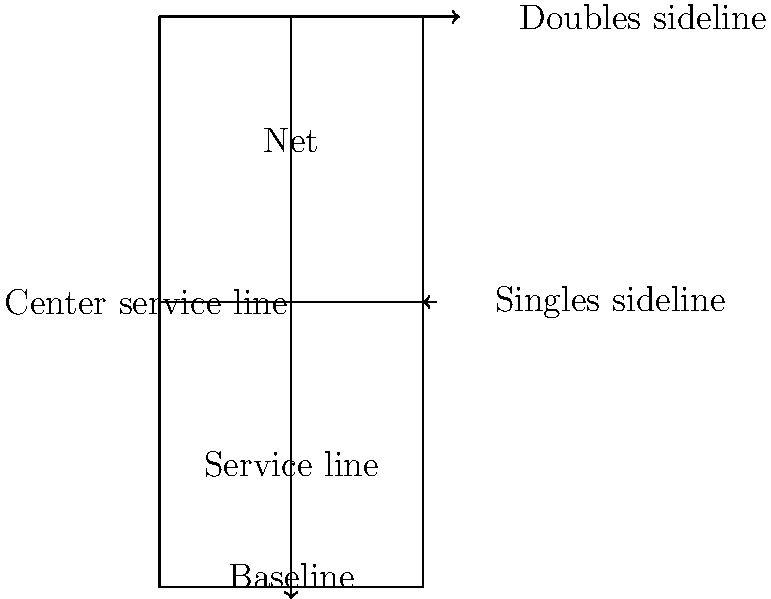A standard tennis court has dimensions as shown in the diagram above (units in meters). The total court area (including doubles sidelines) is 260.76 m². What percentage of the total court area is taken up by the two service boxes combined? Let's approach this step-by-step:

1) First, let's calculate the dimensions of a single service box:
   Width = Distance from singles sideline to center service line = $5.485 \text{ m}$
   Length = Distance from service line to net = $17.37 \text{ m} - 6.4 \text{ m} = 10.97 \text{ m}$

2) Area of one service box:
   $A_{service box} = 5.485 \text{ m} \times 10.97 \text{ m} = 60.17 \text{ m}^2$

3) There are two service boxes, so total area of service boxes:
   $A_{total service boxes} = 2 \times 60.17 \text{ m}^2 = 120.34 \text{ m}^2$

4) We're given that the total court area is 260.76 m². To calculate the percentage:

   $\text{Percentage} = \frac{A_{total service boxes}}{A_{total court}} \times 100\%$

   $= \frac{120.34 \text{ m}^2}{260.76 \text{ m}^2} \times 100\%$
   
   $= 0.4615 \times 100\% = 46.15\%$

Therefore, the two service boxes combined take up 46.15% of the total court area.
Answer: 46.15% 